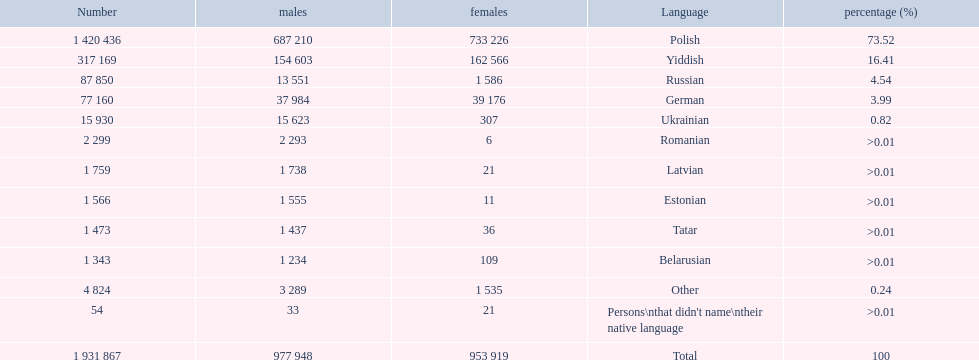How many languages are shown? Polish, Yiddish, Russian, German, Ukrainian, Romanian, Latvian, Estonian, Tatar, Belarusian, Other. What language is in third place? Russian. What language is the most spoken after that one? German. 